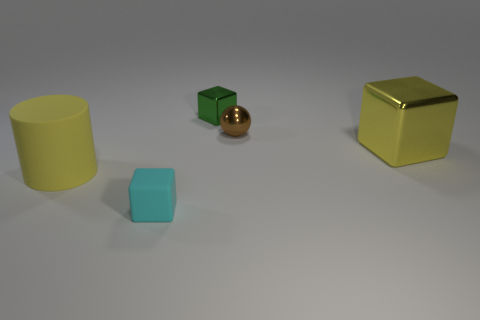Subtract all tiny metal cubes. How many cubes are left? 2 Add 2 tiny red metallic objects. How many objects exist? 7 Subtract all cyan blocks. How many blocks are left? 2 Subtract all cylinders. How many objects are left? 4 Subtract all blue spheres. How many cyan cylinders are left? 0 Subtract all big red metallic spheres. Subtract all large yellow cylinders. How many objects are left? 4 Add 4 big metal blocks. How many big metal blocks are left? 5 Add 1 small brown shiny balls. How many small brown shiny balls exist? 2 Subtract 0 blue cylinders. How many objects are left? 5 Subtract 1 cylinders. How many cylinders are left? 0 